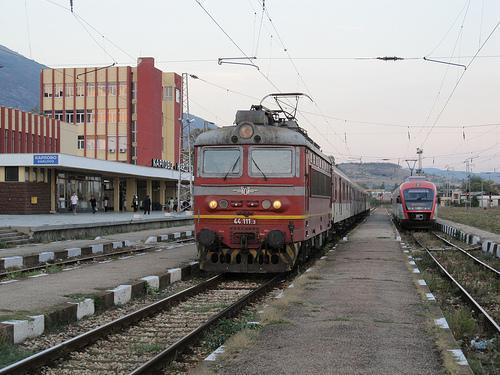How many trains are there?
Give a very brief answer. 2. 